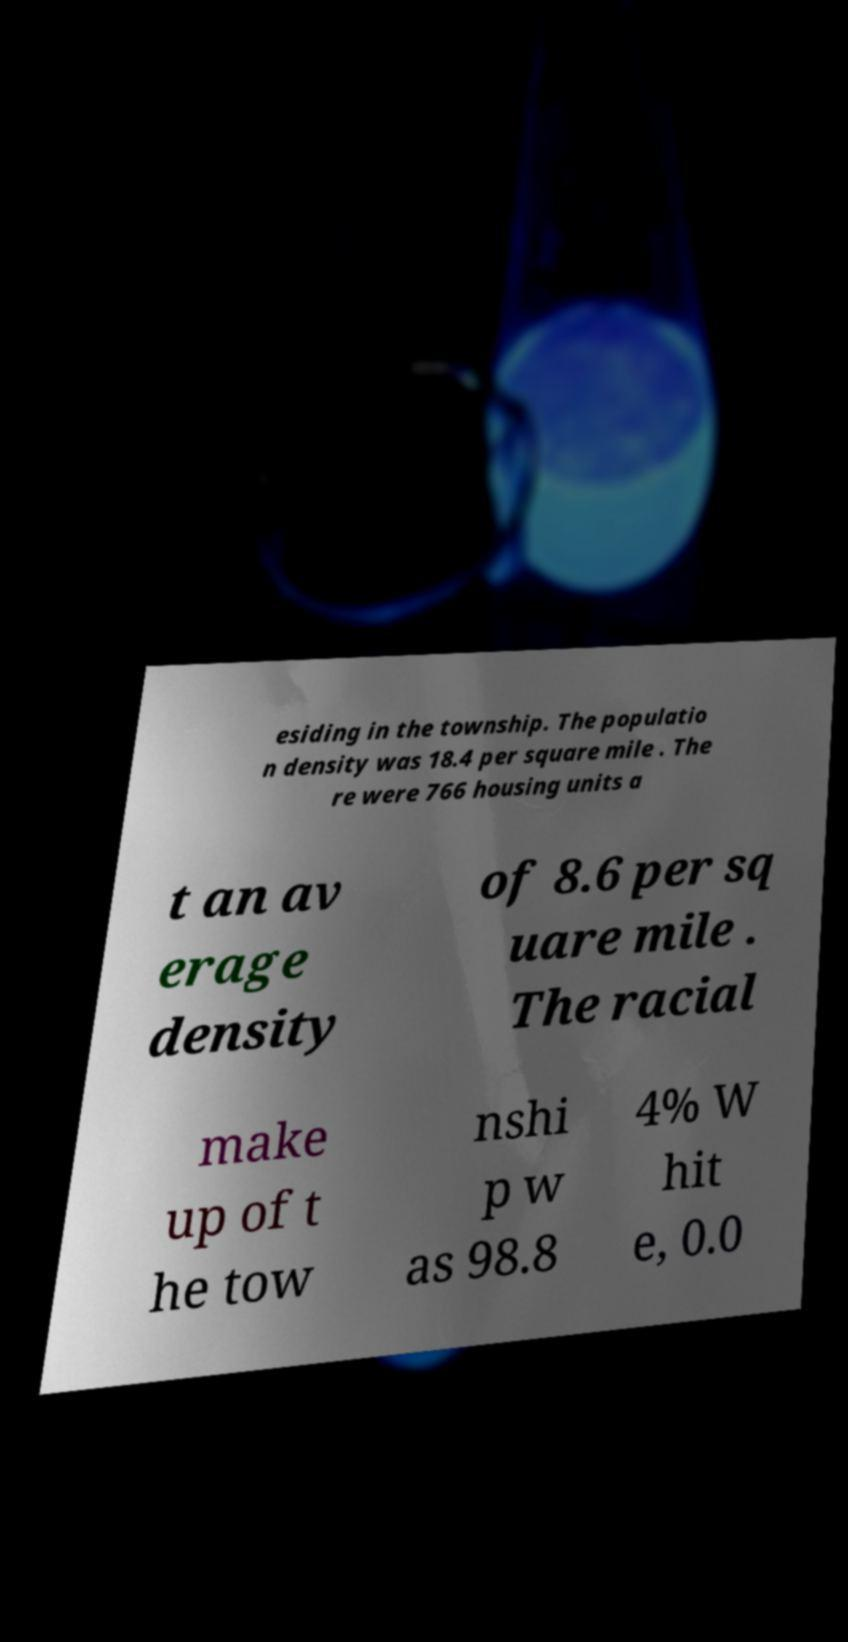Please read and relay the text visible in this image. What does it say? esiding in the township. The populatio n density was 18.4 per square mile . The re were 766 housing units a t an av erage density of 8.6 per sq uare mile . The racial make up of t he tow nshi p w as 98.8 4% W hit e, 0.0 